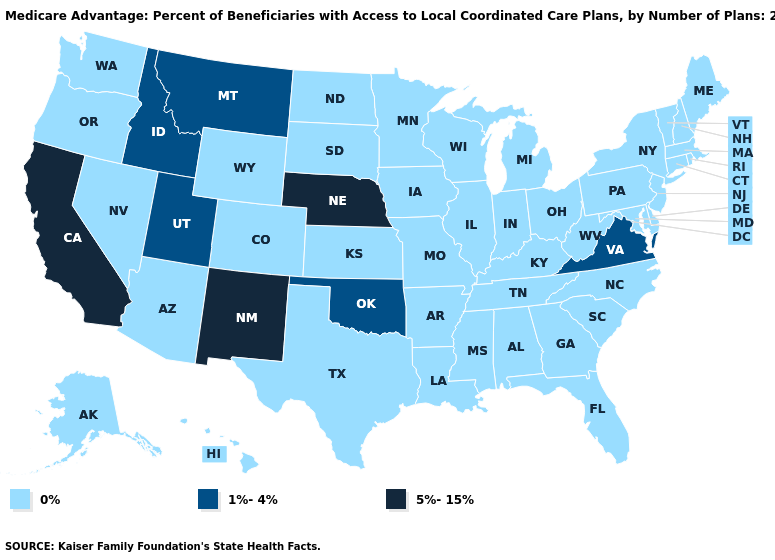Which states hav the highest value in the MidWest?
Concise answer only. Nebraska. What is the value of Rhode Island?
Quick response, please. 0%. What is the highest value in states that border Georgia?
Concise answer only. 0%. What is the value of Texas?
Short answer required. 0%. Which states have the highest value in the USA?
Answer briefly. California, Nebraska, New Mexico. Among the states that border Oklahoma , does New Mexico have the lowest value?
Concise answer only. No. What is the value of Ohio?
Quick response, please. 0%. Does Kansas have the same value as Nebraska?
Keep it brief. No. Does Delaware have the lowest value in the USA?
Concise answer only. Yes. Which states have the highest value in the USA?
Be succinct. California, Nebraska, New Mexico. Name the states that have a value in the range 5%-15%?
Keep it brief. California, Nebraska, New Mexico. Name the states that have a value in the range 5%-15%?
Answer briefly. California, Nebraska, New Mexico. What is the highest value in the MidWest ?
Quick response, please. 5%-15%. 